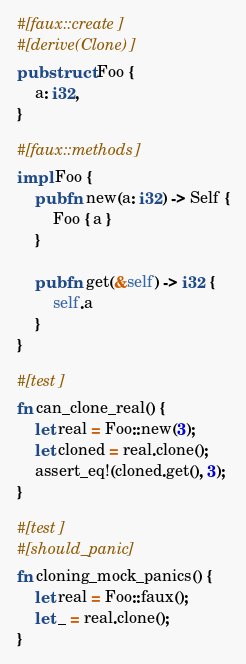Convert code to text. <code><loc_0><loc_0><loc_500><loc_500><_Rust_>#[faux::create]
#[derive(Clone)]
pub struct Foo {
    a: i32,
}

#[faux::methods]
impl Foo {
    pub fn new(a: i32) -> Self {
        Foo { a }
    }

    pub fn get(&self) -> i32 {
        self.a
    }
}

#[test]
fn can_clone_real() {
    let real = Foo::new(3);
    let cloned = real.clone();
    assert_eq!(cloned.get(), 3);
}

#[test]
#[should_panic]
fn cloning_mock_panics() {
    let real = Foo::faux();
    let _ = real.clone();
}
</code> 